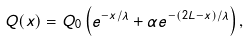Convert formula to latex. <formula><loc_0><loc_0><loc_500><loc_500>Q ( x ) = Q _ { 0 } \left ( e ^ { - x / \lambda } + \alpha e ^ { - ( 2 L - x ) / \lambda } \right ) ,</formula> 